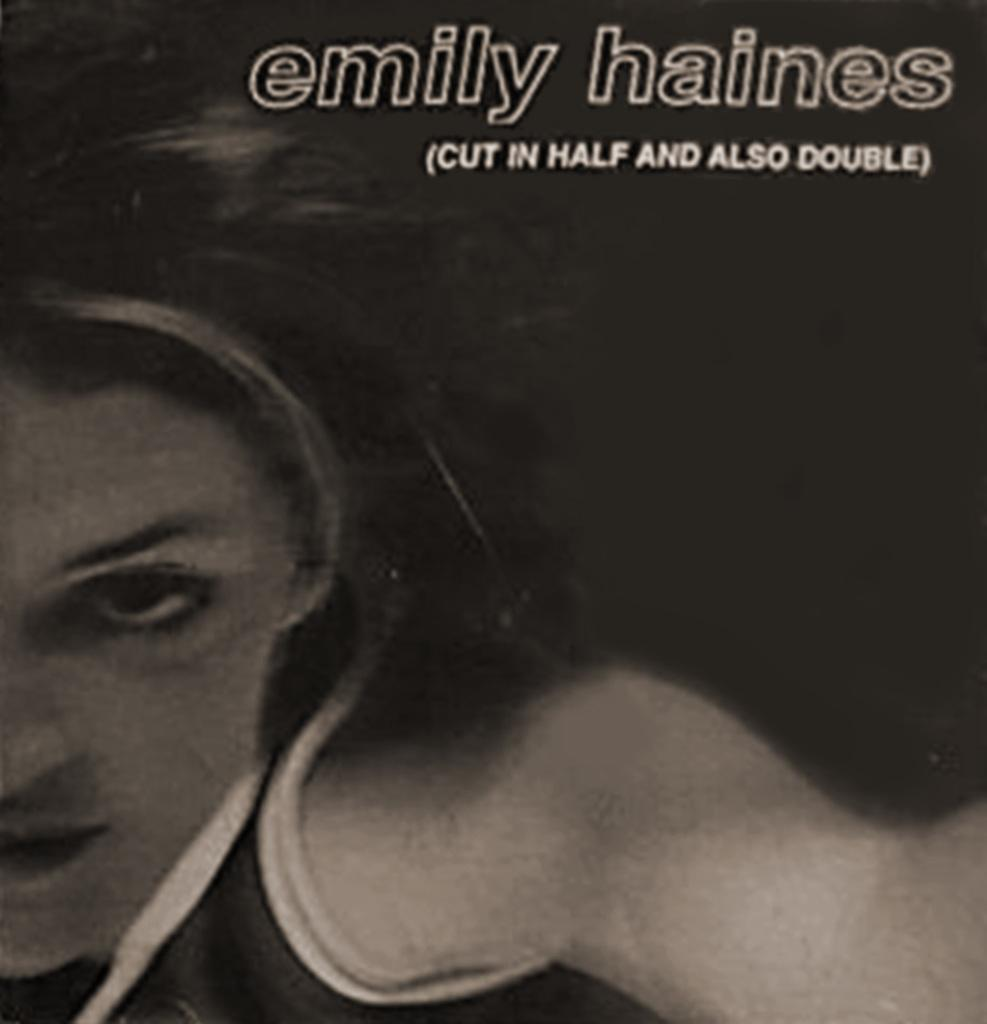What is present in the image that features a design or message? There is a poster in the image. Who is depicted on the poster? The poster features a woman. What else can be seen on the poster besides the image of the woman? There is text written on the poster. What type of shirt is the fireman wearing in the image? There is no fireman or shirt present in the image; it features a poster with a woman and text. 